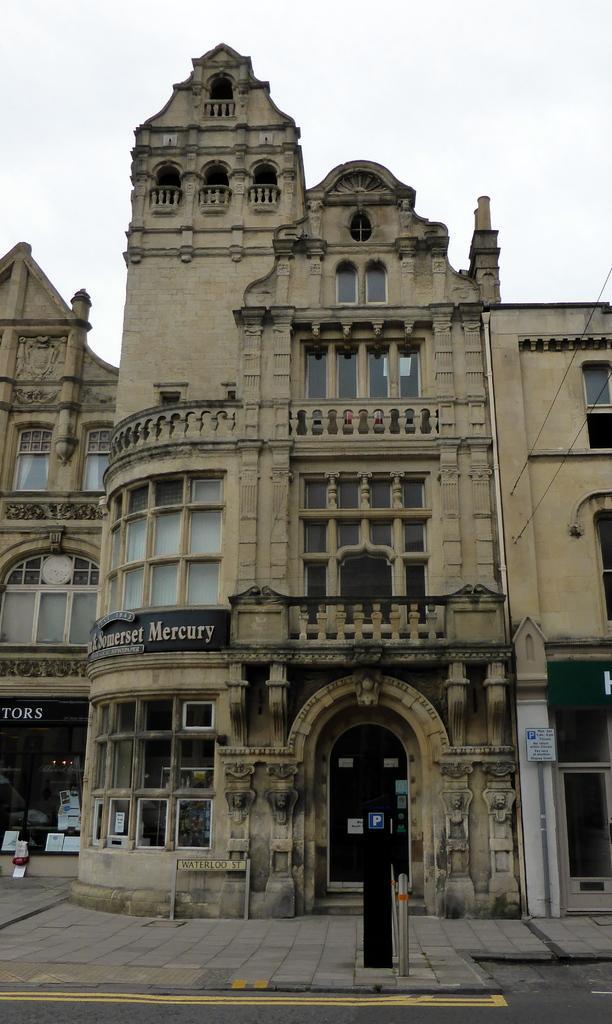Describe this image in one or two sentences. In this image I can see the road. In the background, I can see the buildings with some text written on it. At the top I can see the sky. 